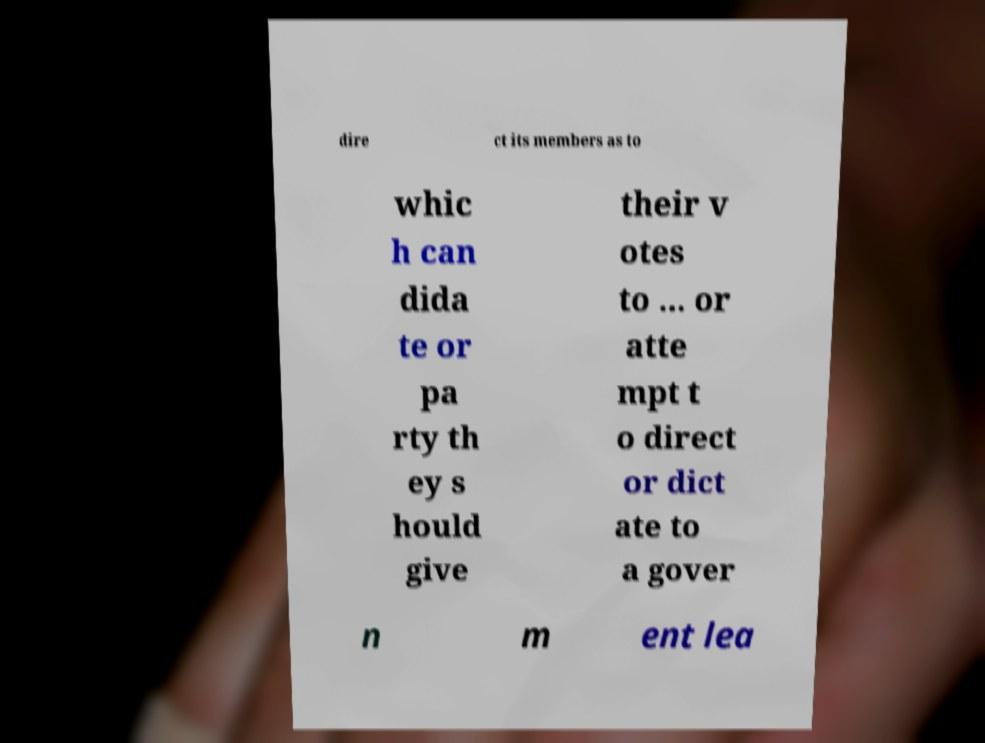What messages or text are displayed in this image? I need them in a readable, typed format. dire ct its members as to whic h can dida te or pa rty th ey s hould give their v otes to ... or atte mpt t o direct or dict ate to a gover n m ent lea 